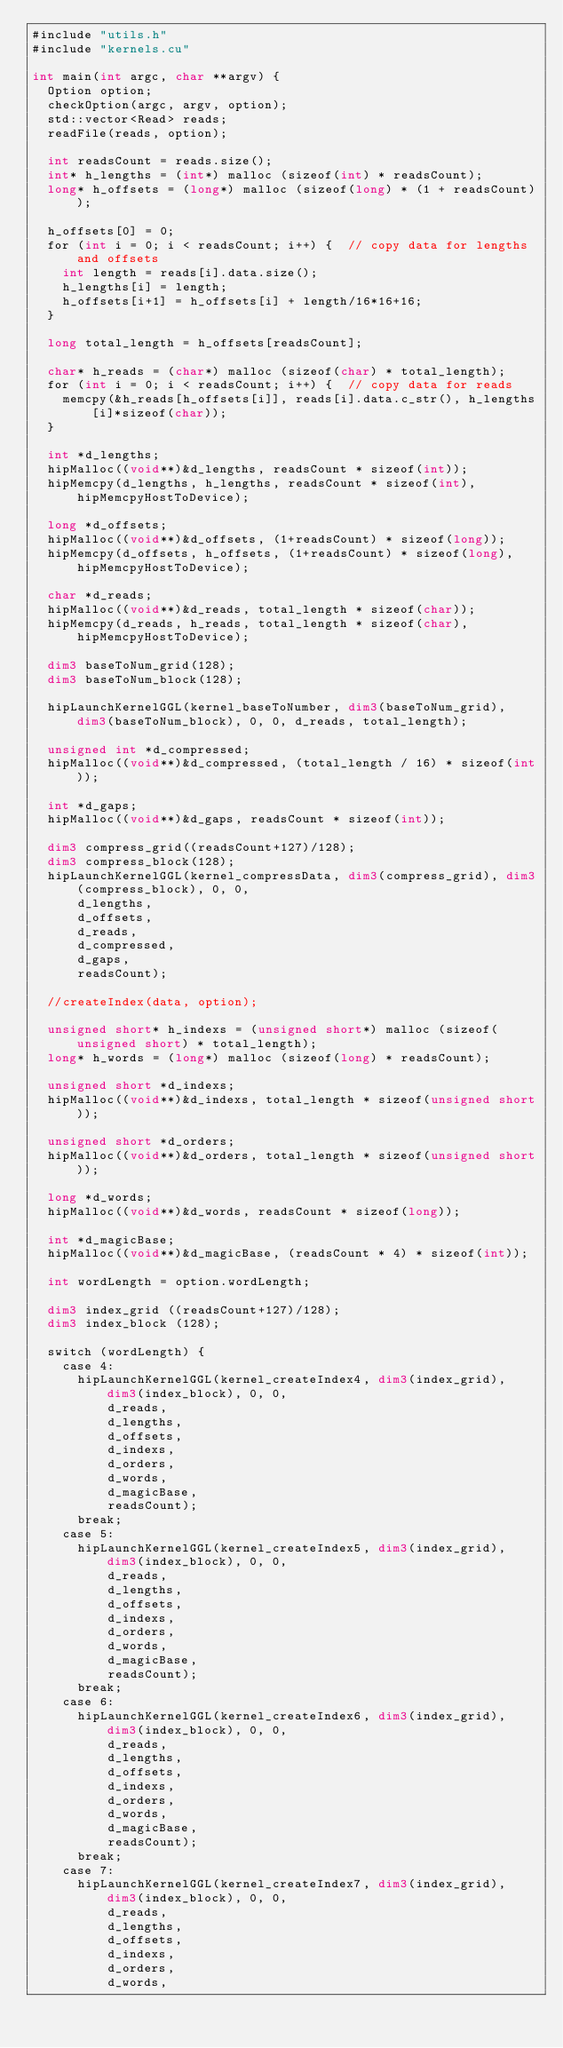Convert code to text. <code><loc_0><loc_0><loc_500><loc_500><_Cuda_>#include "utils.h"
#include "kernels.cu"

int main(int argc, char **argv) {
  Option option;
  checkOption(argc, argv, option);
  std::vector<Read> reads;
  readFile(reads, option);

  int readsCount = reads.size();
  int* h_lengths = (int*) malloc (sizeof(int) * readsCount);
  long* h_offsets = (long*) malloc (sizeof(long) * (1 + readsCount));

  h_offsets[0] = 0;
  for (int i = 0; i < readsCount; i++) {  // copy data for lengths and offsets
    int length = reads[i].data.size();
    h_lengths[i] = length;
    h_offsets[i+1] = h_offsets[i] + length/16*16+16;
  }

  long total_length = h_offsets[readsCount];

  char* h_reads = (char*) malloc (sizeof(char) * total_length);
  for (int i = 0; i < readsCount; i++) {  // copy data for reads
    memcpy(&h_reads[h_offsets[i]], reads[i].data.c_str(), h_lengths[i]*sizeof(char));
  }

  int *d_lengths; 
  hipMalloc((void**)&d_lengths, readsCount * sizeof(int));
  hipMemcpy(d_lengths, h_lengths, readsCount * sizeof(int), hipMemcpyHostToDevice);

  long *d_offsets; 
  hipMalloc((void**)&d_offsets, (1+readsCount) * sizeof(long));
  hipMemcpy(d_offsets, h_offsets, (1+readsCount) * sizeof(long), hipMemcpyHostToDevice);

  char *d_reads; 
  hipMalloc((void**)&d_reads, total_length * sizeof(char));
  hipMemcpy(d_reads, h_reads, total_length * sizeof(char), hipMemcpyHostToDevice);

  dim3 baseToNum_grid(128);
  dim3 baseToNum_block(128);

  hipLaunchKernelGGL(kernel_baseToNumber, dim3(baseToNum_grid), dim3(baseToNum_block), 0, 0, d_reads, total_length);

  unsigned int *d_compressed;
  hipMalloc((void**)&d_compressed, (total_length / 16) * sizeof(int));

  int *d_gaps;
  hipMalloc((void**)&d_gaps, readsCount * sizeof(int));

  dim3 compress_grid((readsCount+127)/128);
  dim3 compress_block(128);
  hipLaunchKernelGGL(kernel_compressData, dim3(compress_grid), dim3(compress_block), 0, 0, 
      d_lengths,
      d_offsets, 
      d_reads, 
      d_compressed, 
      d_gaps, 
      readsCount);

  //createIndex(data, option);

  unsigned short* h_indexs = (unsigned short*) malloc (sizeof(unsigned short) * total_length);
  long* h_words = (long*) malloc (sizeof(long) * readsCount);

  unsigned short *d_indexs;
  hipMalloc((void**)&d_indexs, total_length * sizeof(unsigned short)); 

  unsigned short *d_orders;
  hipMalloc((void**)&d_orders, total_length * sizeof(unsigned short)); 

  long *d_words;
  hipMalloc((void**)&d_words, readsCount * sizeof(long)); 

  int *d_magicBase;
  hipMalloc((void**)&d_magicBase, (readsCount * 4) * sizeof(int)); 

  int wordLength = option.wordLength;

  dim3 index_grid ((readsCount+127)/128);
  dim3 index_block (128);

  switch (wordLength) {
    case 4:
      hipLaunchKernelGGL(kernel_createIndex4, dim3(index_grid), dim3(index_block), 0, 0, 
          d_reads, 
          d_lengths,
          d_offsets, 
          d_indexs,
          d_orders,
          d_words, 
          d_magicBase, 
          readsCount);
      break;
    case 5:
      hipLaunchKernelGGL(kernel_createIndex5, dim3(index_grid), dim3(index_block), 0, 0, 
          d_reads, 
          d_lengths,
          d_offsets, 
          d_indexs,
          d_orders,
          d_words, 
          d_magicBase, 
          readsCount);
      break;
    case 6:
      hipLaunchKernelGGL(kernel_createIndex6, dim3(index_grid), dim3(index_block), 0, 0, 
          d_reads, 
          d_lengths,
          d_offsets, 
          d_indexs,
          d_orders,
          d_words, 
          d_magicBase, 
          readsCount);
      break;
    case 7:
      hipLaunchKernelGGL(kernel_createIndex7, dim3(index_grid), dim3(index_block), 0, 0, 
          d_reads, 
          d_lengths,
          d_offsets, 
          d_indexs,
          d_orders,
          d_words, </code> 